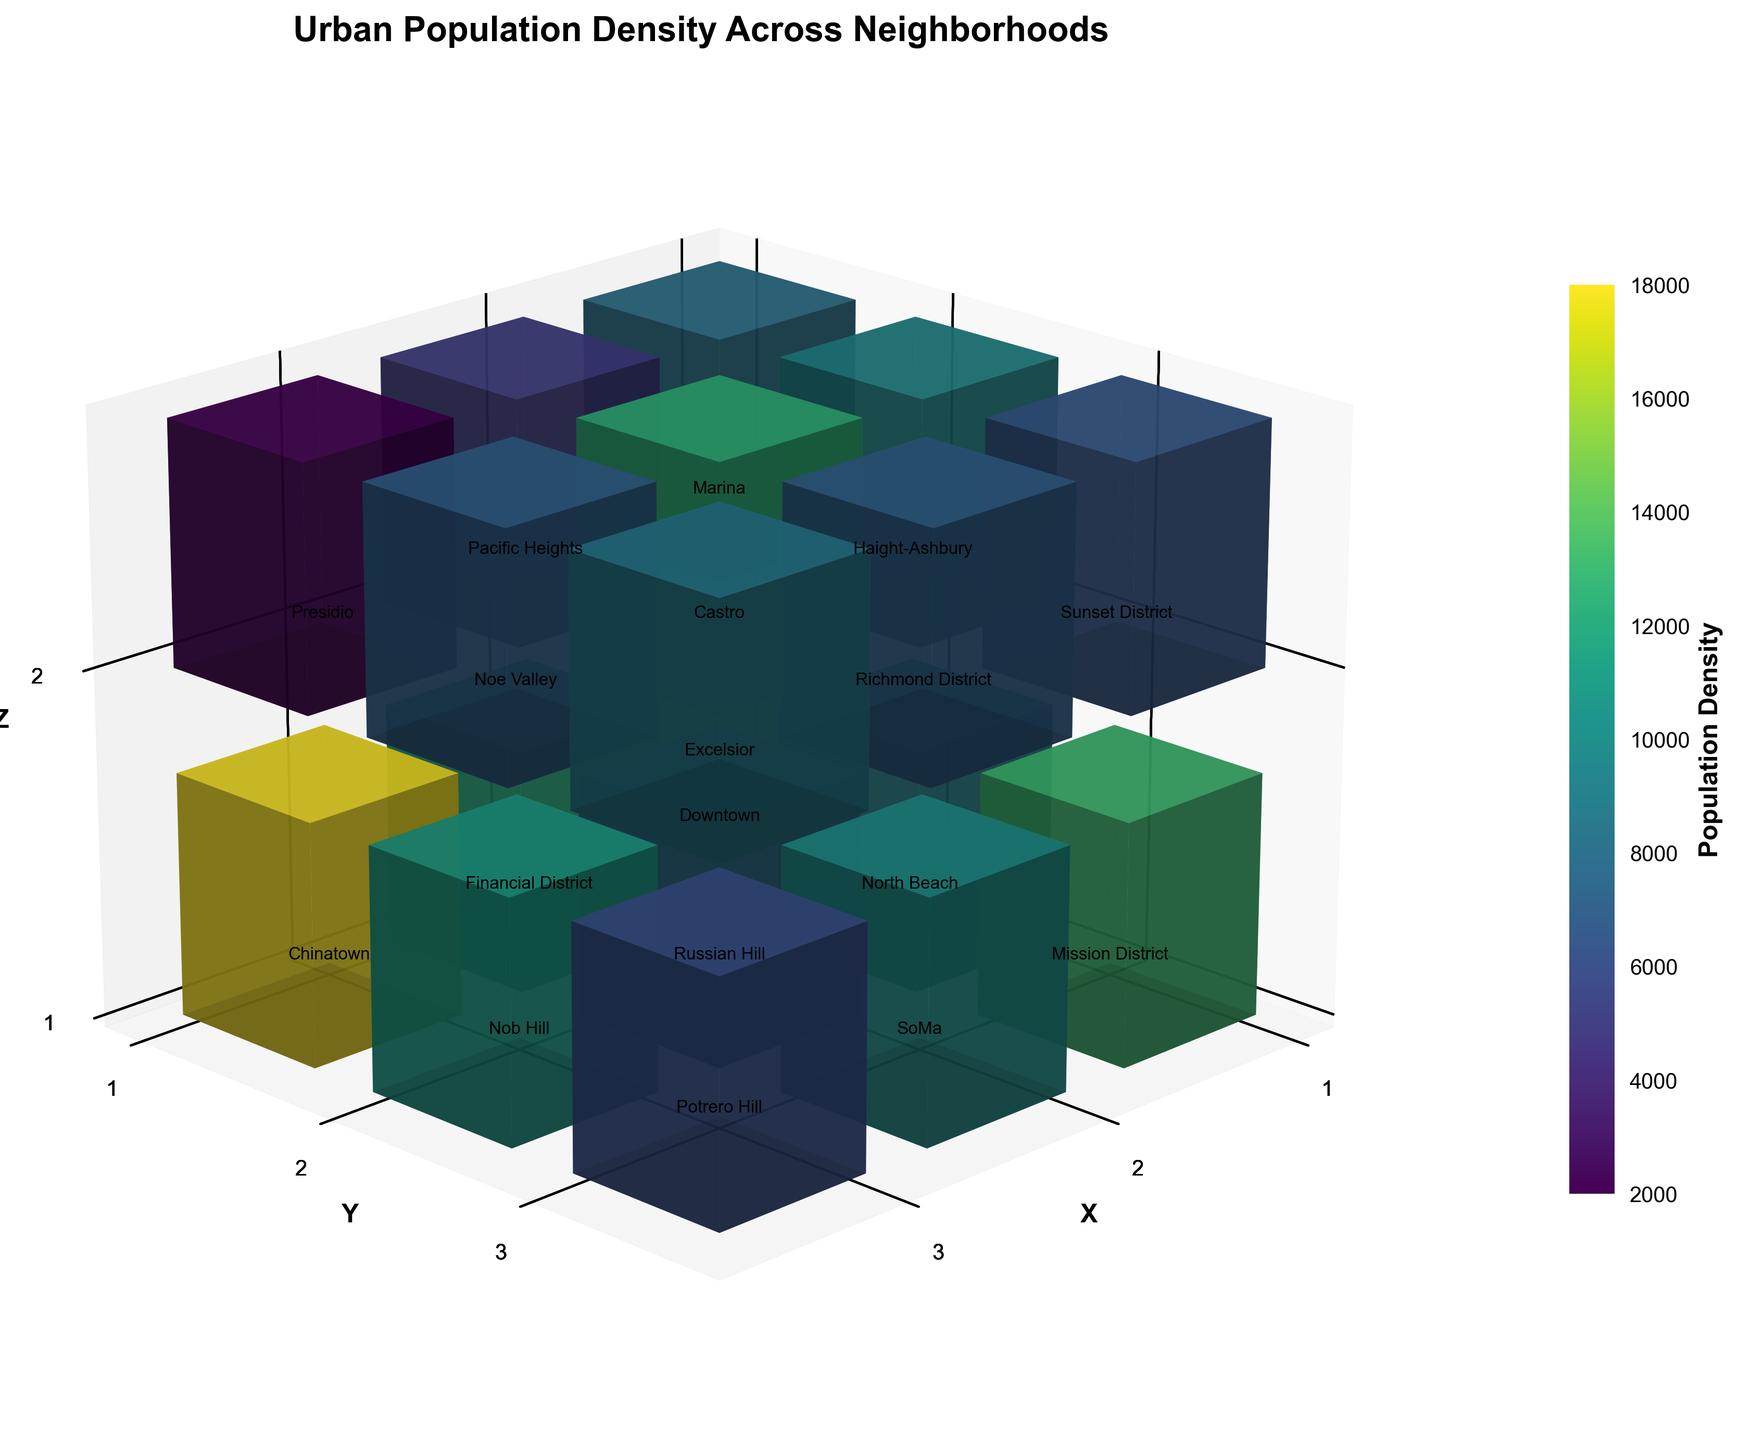What is the title of the figure? The title is usually found at the top of the figure, in this case, it is clearly specified.
Answer: Urban Population Density Across Neighborhoods Which neighborhood has the highest population density? By examining the color bar and comparing the intensity of colors representing population densities, Chinatown has the highest density as indicated by the darkest color.
Answer: Chinatown What neighborhood is represented by the coordinates (2, 2, 2)? By locating the point at (2, 2, 2) on the 3D bar graph, the neighborhood with these coordinates can be identified.
Answer: Castro How many neighborhoods have a population density above 10000? By examining the color intensities and referring to the color bar, neighborhoods with higher population densities are identified. Counting these neighborhoods gives us the answer.
Answer: 7 Which neighborhood has a lower population density, Marina or Richmond District? Comparing the color intensities at the coordinates representing Marina and Richmond District, the lighter color indicates a lower density.
Answer: Marina What neighborhood is located at the highest Z coordinate and what is its population density? Identifying the highest Z coordinate (2) and locating the corresponding neighborhood gives us the answer. Then, the density is found from the color and legend.
Answer: Presidio, 2000 What is the sum of population densities for Downtown and Financial District? Retrieve the population densities for both neighborhoods from the data and add them together: 15000 + 12000 = 27000.
Answer: 27000 Which neighborhood lies at the coordinates (1, 3, 1) and what is its population density? By finding the point at (1, 3, 1) on the 3D bar graph, the neighborhood and its associated density can be identified.
Answer: Mission District, 13000 Is there any neighborhood at Z = 3? Observing the Z-axis, there are only neighborhoods at Z=1 and Z=2.
Answer: No How do the population densities of Noe Valley and Haight-Ashbury compare? Locate both neighborhoods on the 3D graph and compare their color intensities to determine which one has higher population density.
Answer: Haight-Ashbury has higher density 